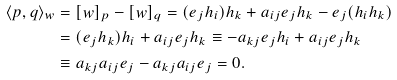<formula> <loc_0><loc_0><loc_500><loc_500>\langle p , q \rangle _ { w } & = [ w ] _ { p } - [ w ] _ { q } = ( e _ { j } h _ { i } ) h _ { k } + a _ { i j } e _ { j } h _ { k } - e _ { j } ( h _ { i } h _ { k } ) \\ & = ( e _ { j } h _ { k } ) h _ { i } + a _ { i j } e _ { j } h _ { k } \equiv - a _ { k j } e _ { j } h _ { i } + a _ { i j } e _ { j } h _ { k } \\ & \equiv a _ { k j } a _ { i j } e _ { j } - a _ { k j } a _ { i j } e _ { j } = 0 .</formula> 